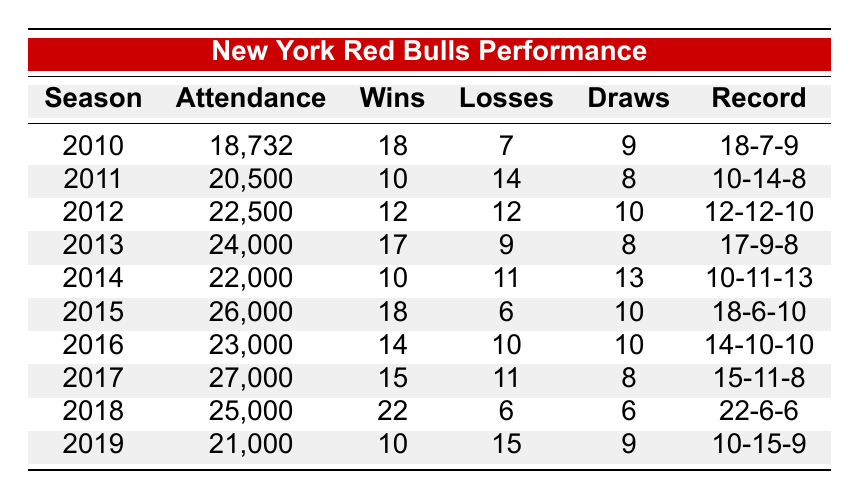What was the attendance in the 2018 season? The table shows that the attendance for the 2018 season is listed directly under the "Attendance" column for that season. Looking at the row for 2018, the attendance is 25,000.
Answer: 25,000 Which season had the highest win-loss record? To determine the highest win-loss record, we look at the "Record" column and compare the win figures. The season with the highest wins is 2018, with 22 wins, resulting in the record of 22-6-6.
Answer: 2018 In which season did the Red Bulls have more losses than wins? We can review the "Wins" and "Losses" columns for each season. The seasons with more losses than wins are 2011 (10 wins, 14 losses) and 2019 (10 wins, 15 losses).
Answer: 2011, 2019 What is the average attendance for the seasons between 2010 and 2015? First, we sum the attendance figures for the seasons from 2010 to 2015: 18,732 + 20,500 + 22,500 + 24,000 + 22,000 + 26,000 = 133,732. There are 6 seasons in total, so we calculate the average by dividing the total by 6: 133,732 / 6 = 22,288.67.
Answer: 22,288.67 Did the Red Bulls achieve a win-loss record of 18-6 or better in more than two seasons? We need to identify all seasons with a record of 18 wins and 6 losses or better. These seasons are 2010 (18-7-9) and 2015 (18-6-10). Since there are only two seasons that meet this criterion, the answer is no.
Answer: No What were the wins and losses in the season with the second highest attendance? To find the season with the second highest attendance, we look at the "Attendance" column. The highest is 2017 with 27,000, and the second highest is 2018 with 25,000. For 2018, the wins are 22 and losses are 6.
Answer: 22 wins, 6 losses Which season had the lowest attendance, and what was the win-loss record for that season? The lowest attendance is found by scanning the "Attendance" column. The lowest number is 18,732 in 2010. Looking at the same row, the win-loss record is 18-7-9.
Answer: 2010, 18-7-9 How many seasons had 14 or more wins? We will check the "Wins" column and count the number of seasons with 14 or more wins. These are the seasons 2013 (17 wins), 2015 (18 wins), 2017 (15 wins), and 2018 (22 wins), resulting in a total of 4 seasons.
Answer: 4 